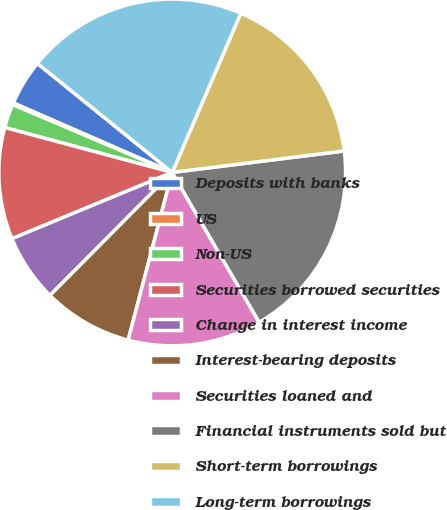Convert chart to OTSL. <chart><loc_0><loc_0><loc_500><loc_500><pie_chart><fcel>Deposits with banks<fcel>US<fcel>Non-US<fcel>Securities borrowed securities<fcel>Change in interest income<fcel>Interest-bearing deposits<fcel>Securities loaned and<fcel>Financial instruments sold but<fcel>Short-term borrowings<fcel>Long-term borrowings<nl><fcel>4.26%<fcel>0.17%<fcel>2.22%<fcel>10.41%<fcel>6.31%<fcel>8.36%<fcel>12.46%<fcel>18.6%<fcel>16.55%<fcel>20.65%<nl></chart> 